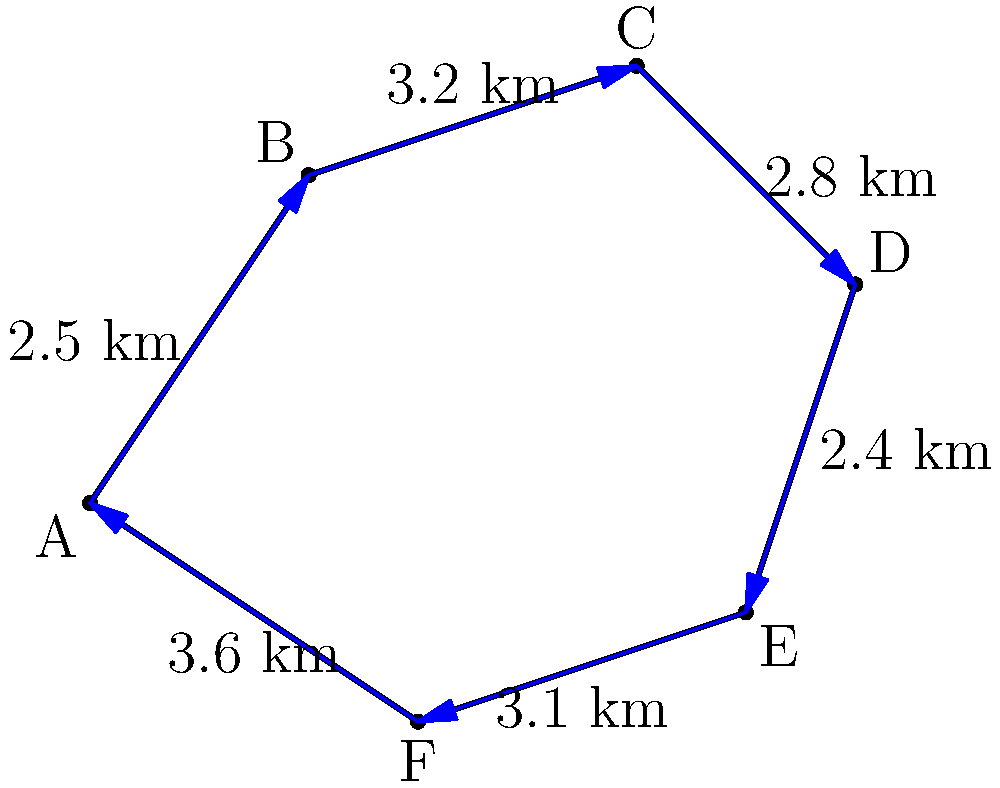As a devoted Catholic, you're planning a pilgrimage to Vatican City. You've obtained a map of its unique, irregular shape. The borders are represented by six segments, each with a known length in kilometers. Calculate the perimeter of Vatican City to determine the length of a prayerful walk around its entirety. Round your answer to the nearest tenth of a kilometer. To calculate the perimeter of Vatican City, we need to sum the lengths of all six border segments. Let's approach this step-by-step:

1. Identify the lengths of each segment:
   AB = 2.5 km
   BC = 3.2 km
   CD = 2.8 km
   DE = 2.4 km
   EF = 3.1 km
   FA = 3.6 km

2. Add all these lengths together:
   $$ \text{Perimeter} = AB + BC + CD + DE + EF + FA $$
   $$ = 2.5 + 3.2 + 2.8 + 2.4 + 3.1 + 3.6 $$
   $$ = 17.6 \text{ km} $$

3. The question asks to round to the nearest tenth of a kilometer, but 17.6 km is already in that form.

Thus, the perimeter of Vatican City, representing the length of a prayerful walk around its entirety, is 17.6 km.
Answer: 17.6 km 